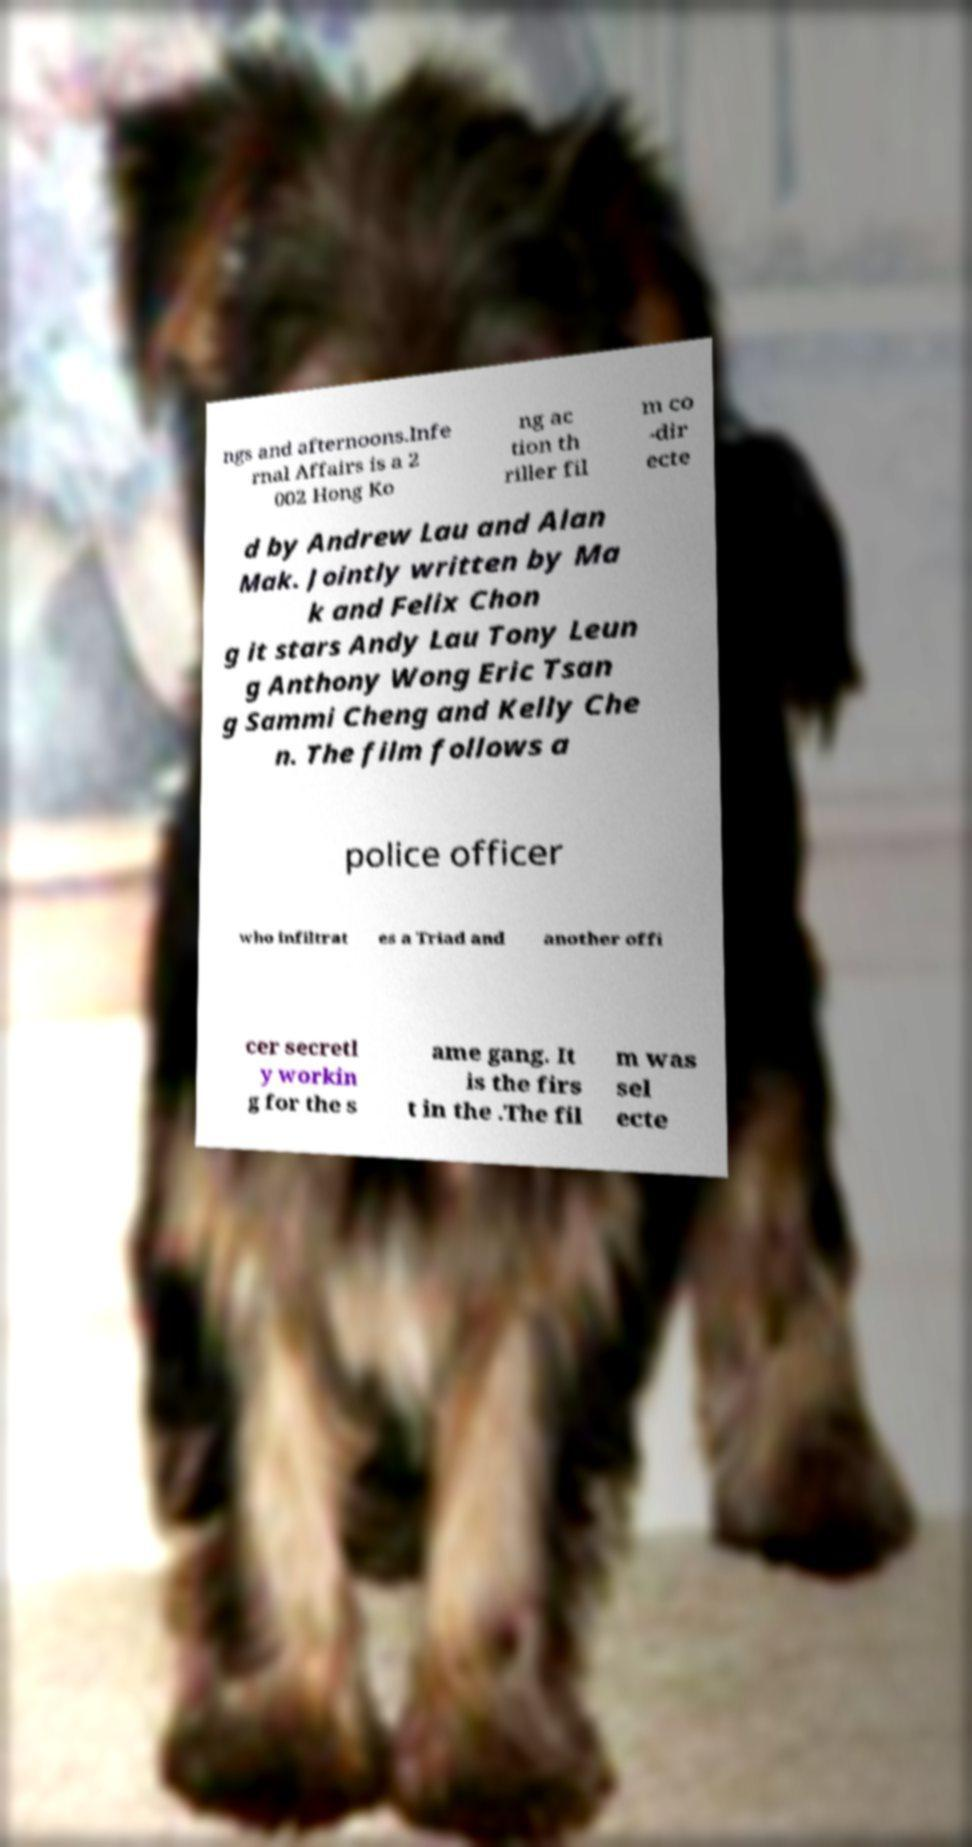Could you assist in decoding the text presented in this image and type it out clearly? ngs and afternoons.Infe rnal Affairs is a 2 002 Hong Ko ng ac tion th riller fil m co -dir ecte d by Andrew Lau and Alan Mak. Jointly written by Ma k and Felix Chon g it stars Andy Lau Tony Leun g Anthony Wong Eric Tsan g Sammi Cheng and Kelly Che n. The film follows a police officer who infiltrat es a Triad and another offi cer secretl y workin g for the s ame gang. It is the firs t in the .The fil m was sel ecte 